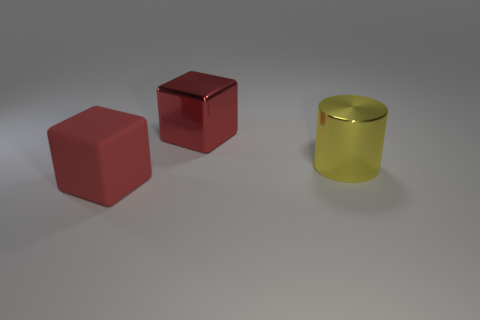Add 3 big purple rubber cubes. How many objects exist? 6 Subtract all cylinders. How many objects are left? 2 Subtract all big red blocks. Subtract all shiny cylinders. How many objects are left? 0 Add 2 red metal cubes. How many red metal cubes are left? 3 Add 2 tiny green metal cylinders. How many tiny green metal cylinders exist? 2 Subtract 0 blue balls. How many objects are left? 3 